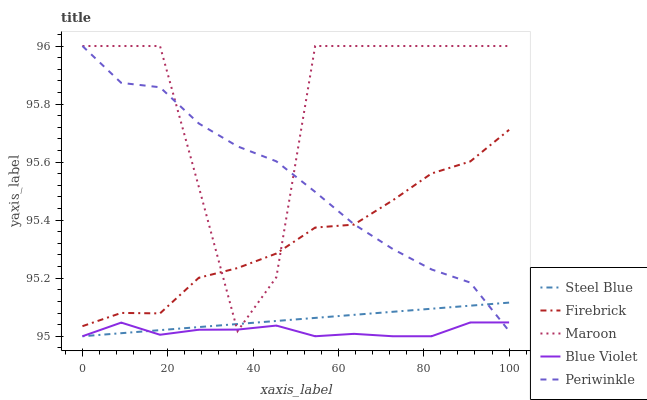Does Blue Violet have the minimum area under the curve?
Answer yes or no. Yes. Does Maroon have the maximum area under the curve?
Answer yes or no. Yes. Does Firebrick have the minimum area under the curve?
Answer yes or no. No. Does Firebrick have the maximum area under the curve?
Answer yes or no. No. Is Steel Blue the smoothest?
Answer yes or no. Yes. Is Maroon the roughest?
Answer yes or no. Yes. Is Firebrick the smoothest?
Answer yes or no. No. Is Firebrick the roughest?
Answer yes or no. No. Does Blue Violet have the lowest value?
Answer yes or no. Yes. Does Periwinkle have the lowest value?
Answer yes or no. No. Does Maroon have the highest value?
Answer yes or no. Yes. Does Firebrick have the highest value?
Answer yes or no. No. Is Steel Blue less than Firebrick?
Answer yes or no. Yes. Is Firebrick greater than Blue Violet?
Answer yes or no. Yes. Does Maroon intersect Periwinkle?
Answer yes or no. Yes. Is Maroon less than Periwinkle?
Answer yes or no. No. Is Maroon greater than Periwinkle?
Answer yes or no. No. Does Steel Blue intersect Firebrick?
Answer yes or no. No. 